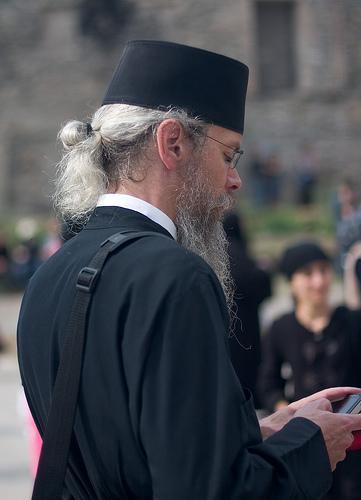How many men are there?
Give a very brief answer. 1. 